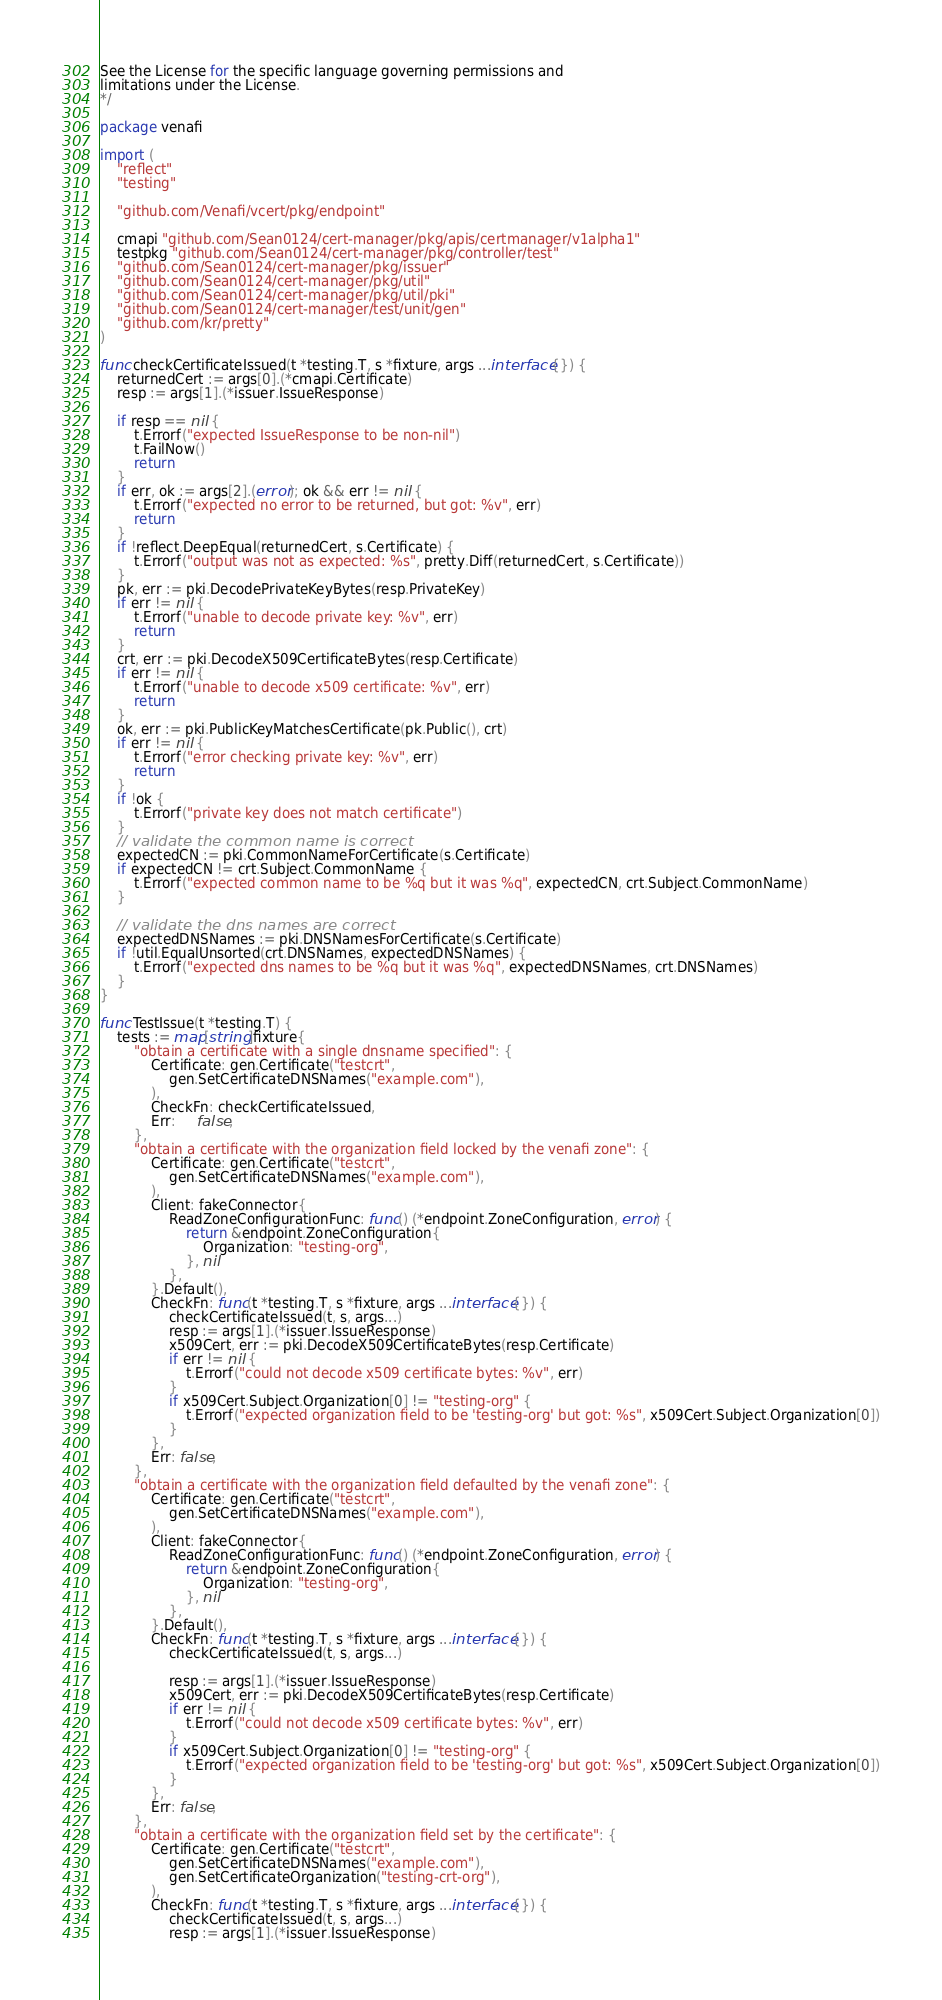<code> <loc_0><loc_0><loc_500><loc_500><_Go_>See the License for the specific language governing permissions and
limitations under the License.
*/

package venafi

import (
	"reflect"
	"testing"

	"github.com/Venafi/vcert/pkg/endpoint"

	cmapi "github.com/Sean0124/cert-manager/pkg/apis/certmanager/v1alpha1"
	testpkg "github.com/Sean0124/cert-manager/pkg/controller/test"
	"github.com/Sean0124/cert-manager/pkg/issuer"
	"github.com/Sean0124/cert-manager/pkg/util"
	"github.com/Sean0124/cert-manager/pkg/util/pki"
	"github.com/Sean0124/cert-manager/test/unit/gen"
	"github.com/kr/pretty"
)

func checkCertificateIssued(t *testing.T, s *fixture, args ...interface{}) {
	returnedCert := args[0].(*cmapi.Certificate)
	resp := args[1].(*issuer.IssueResponse)

	if resp == nil {
		t.Errorf("expected IssueResponse to be non-nil")
		t.FailNow()
		return
	}
	if err, ok := args[2].(error); ok && err != nil {
		t.Errorf("expected no error to be returned, but got: %v", err)
		return
	}
	if !reflect.DeepEqual(returnedCert, s.Certificate) {
		t.Errorf("output was not as expected: %s", pretty.Diff(returnedCert, s.Certificate))
	}
	pk, err := pki.DecodePrivateKeyBytes(resp.PrivateKey)
	if err != nil {
		t.Errorf("unable to decode private key: %v", err)
		return
	}
	crt, err := pki.DecodeX509CertificateBytes(resp.Certificate)
	if err != nil {
		t.Errorf("unable to decode x509 certificate: %v", err)
		return
	}
	ok, err := pki.PublicKeyMatchesCertificate(pk.Public(), crt)
	if err != nil {
		t.Errorf("error checking private key: %v", err)
		return
	}
	if !ok {
		t.Errorf("private key does not match certificate")
	}
	// validate the common name is correct
	expectedCN := pki.CommonNameForCertificate(s.Certificate)
	if expectedCN != crt.Subject.CommonName {
		t.Errorf("expected common name to be %q but it was %q", expectedCN, crt.Subject.CommonName)
	}

	// validate the dns names are correct
	expectedDNSNames := pki.DNSNamesForCertificate(s.Certificate)
	if !util.EqualUnsorted(crt.DNSNames, expectedDNSNames) {
		t.Errorf("expected dns names to be %q but it was %q", expectedDNSNames, crt.DNSNames)
	}
}

func TestIssue(t *testing.T) {
	tests := map[string]fixture{
		"obtain a certificate with a single dnsname specified": {
			Certificate: gen.Certificate("testcrt",
				gen.SetCertificateDNSNames("example.com"),
			),
			CheckFn: checkCertificateIssued,
			Err:     false,
		},
		"obtain a certificate with the organization field locked by the venafi zone": {
			Certificate: gen.Certificate("testcrt",
				gen.SetCertificateDNSNames("example.com"),
			),
			Client: fakeConnector{
				ReadZoneConfigurationFunc: func() (*endpoint.ZoneConfiguration, error) {
					return &endpoint.ZoneConfiguration{
						Organization: "testing-org",
					}, nil
				},
			}.Default(),
			CheckFn: func(t *testing.T, s *fixture, args ...interface{}) {
				checkCertificateIssued(t, s, args...)
				resp := args[1].(*issuer.IssueResponse)
				x509Cert, err := pki.DecodeX509CertificateBytes(resp.Certificate)
				if err != nil {
					t.Errorf("could not decode x509 certificate bytes: %v", err)
				}
				if x509Cert.Subject.Organization[0] != "testing-org" {
					t.Errorf("expected organization field to be 'testing-org' but got: %s", x509Cert.Subject.Organization[0])
				}
			},
			Err: false,
		},
		"obtain a certificate with the organization field defaulted by the venafi zone": {
			Certificate: gen.Certificate("testcrt",
				gen.SetCertificateDNSNames("example.com"),
			),
			Client: fakeConnector{
				ReadZoneConfigurationFunc: func() (*endpoint.ZoneConfiguration, error) {
					return &endpoint.ZoneConfiguration{
						Organization: "testing-org",
					}, nil
				},
			}.Default(),
			CheckFn: func(t *testing.T, s *fixture, args ...interface{}) {
				checkCertificateIssued(t, s, args...)

				resp := args[1].(*issuer.IssueResponse)
				x509Cert, err := pki.DecodeX509CertificateBytes(resp.Certificate)
				if err != nil {
					t.Errorf("could not decode x509 certificate bytes: %v", err)
				}
				if x509Cert.Subject.Organization[0] != "testing-org" {
					t.Errorf("expected organization field to be 'testing-org' but got: %s", x509Cert.Subject.Organization[0])
				}
			},
			Err: false,
		},
		"obtain a certificate with the organization field set by the certificate": {
			Certificate: gen.Certificate("testcrt",
				gen.SetCertificateDNSNames("example.com"),
				gen.SetCertificateOrganization("testing-crt-org"),
			),
			CheckFn: func(t *testing.T, s *fixture, args ...interface{}) {
				checkCertificateIssued(t, s, args...)
				resp := args[1].(*issuer.IssueResponse)</code> 